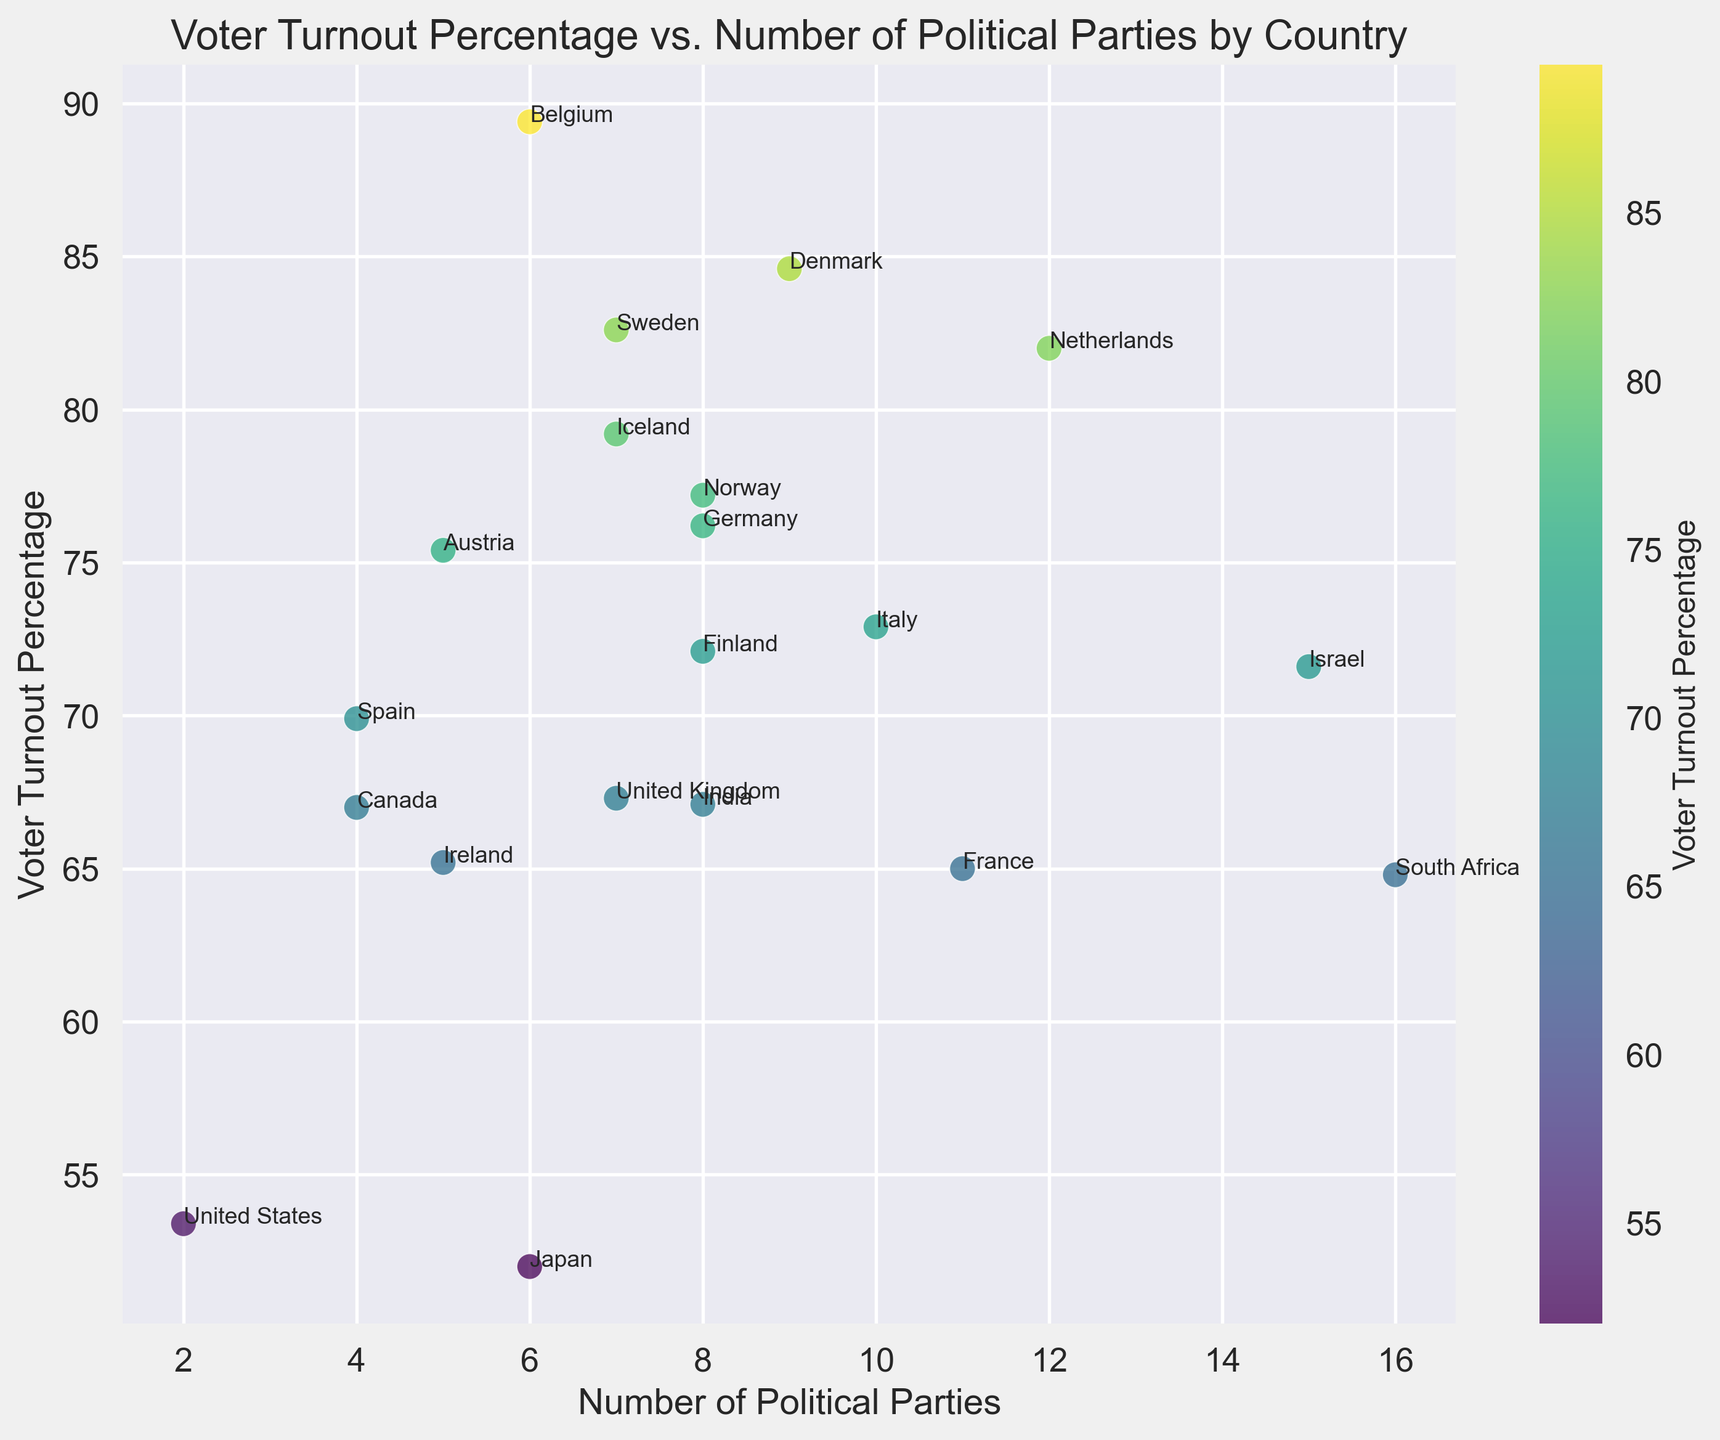What's the voter turnout percentage in Belgium? Look at the scatter plot and identify the data point labeled 'Belgium'. The label next to it indicates that the voter turnout percentage for Belgium is 89.4%
Answer: 89.4% Which country has the lowest number of political parties and what is its voter turnout percentage? Find the data point with the lowest number of political parties. The United States has 2 parties with a voter turnout percentage of 53.4%.
Answer: United States, 53.4% Between Finland and Israel, which country has a higher voter turnout percentage? Look at the scatter plot and identify the data points labeled 'Finland' and 'Israel'. Compare their voter turnout percentages (72.1% for Finland and 71.6% for Israel). Finland has a higher voter turnout percentage.
Answer: Finland What is the average voter turnout percentage for countries with 8 political parties? Identify the data points with 8 political parties (Finland, Germany, India, Italy, and Norway). Sum their voter turnout percentages (72.1 + 76.2 + 67.1 + 72.9 + 77.2) and divide by the number of countries (5). The average is (72.1 + 76.2 + 67.1 + 72.9 + 77.2) / 5 = 73.1%
Answer: 73.1% Which country has the highest voter turnout percentage and how many political parties does it have? Identify the highest point on the scatter plot in terms of voter turnout percentage. The label next to it indicates that the country is Belgium with a voter turnout of 89.4% and it has 6 political parties.
Answer: Belgium, 6 Does any country with more than 10 political parties have a voter turnout percentage higher than 80%? Identify the countries with more than 10 political parties (France, Netherlands, Israel, South Africa). Compare their voter turnout percentages (65.0%, 82.0%, 71.6%, 64.8%). The Netherlands has a voter turnout higher than 80%.
Answer: Yes, Netherlands Is there a positive correlation between the number of political parties and voter turnout percentage? By visually inspecting the scatter plot, check the general trend of the points. The points do not show a clear upward trend; some countries with a higher number of political parties have low voter turnout percentages and vice versa. Therefore, there is no clear positive correlation.
Answer: No Which country with exactly 5 political parties has the highest voter turnout percentage? Look at the data points labeled with '5' political parties (Austria, Ireland). Compare their voter turnout percentages (75.4% for Austria and 65.2% for Ireland). Austria has the highest voter turnout percentage.
Answer: Austria 